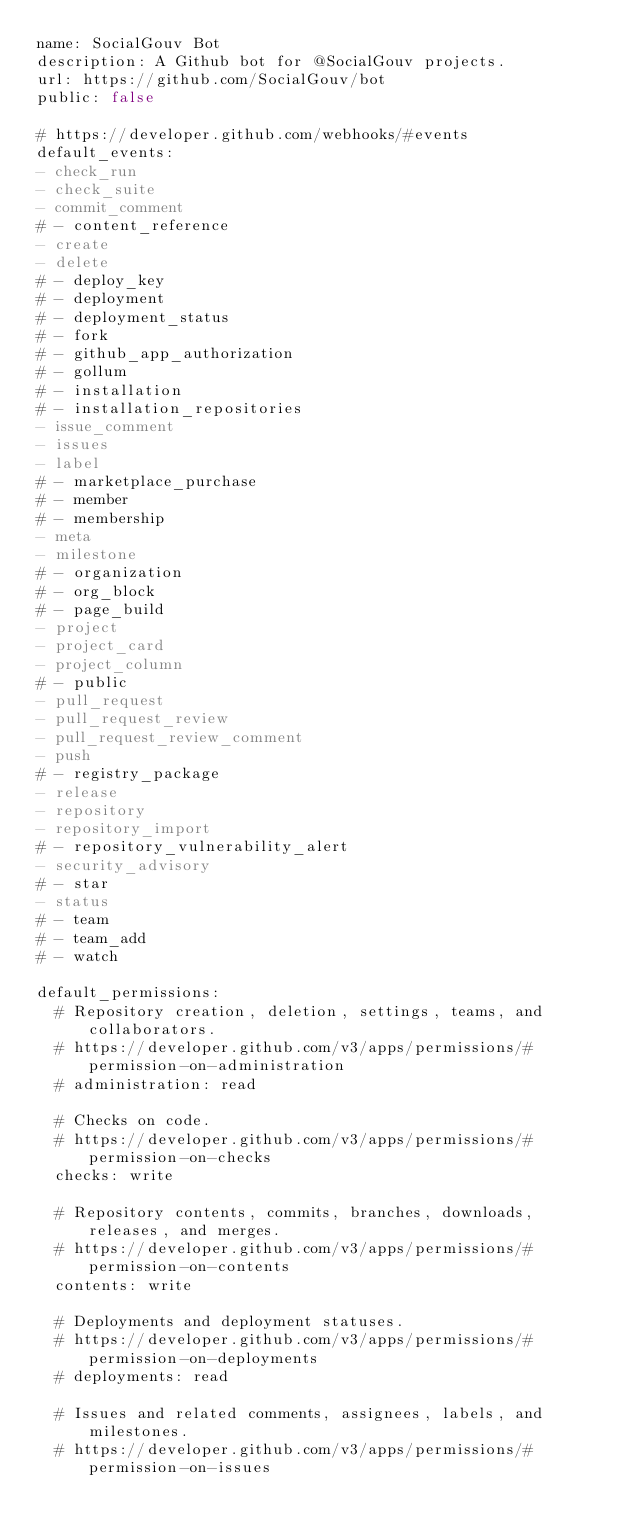<code> <loc_0><loc_0><loc_500><loc_500><_YAML_>name: SocialGouv Bot
description: A Github bot for @SocialGouv projects.
url: https://github.com/SocialGouv/bot
public: false

# https://developer.github.com/webhooks/#events
default_events:
- check_run
- check_suite
- commit_comment
# - content_reference
- create
- delete
# - deploy_key
# - deployment
# - deployment_status
# - fork
# - github_app_authorization
# - gollum
# - installation
# - installation_repositories
- issue_comment
- issues
- label
# - marketplace_purchase
# - member
# - membership
- meta
- milestone
# - organization
# - org_block
# - page_build
- project
- project_card
- project_column
# - public
- pull_request
- pull_request_review
- pull_request_review_comment
- push
# - registry_package
- release
- repository
- repository_import
# - repository_vulnerability_alert
- security_advisory
# - star
- status
# - team
# - team_add
# - watch

default_permissions:
  # Repository creation, deletion, settings, teams, and collaborators.
  # https://developer.github.com/v3/apps/permissions/#permission-on-administration
  # administration: read

  # Checks on code.
  # https://developer.github.com/v3/apps/permissions/#permission-on-checks
  checks: write

  # Repository contents, commits, branches, downloads, releases, and merges.
  # https://developer.github.com/v3/apps/permissions/#permission-on-contents
  contents: write

  # Deployments and deployment statuses.
  # https://developer.github.com/v3/apps/permissions/#permission-on-deployments
  # deployments: read

  # Issues and related comments, assignees, labels, and milestones.
  # https://developer.github.com/v3/apps/permissions/#permission-on-issues</code> 